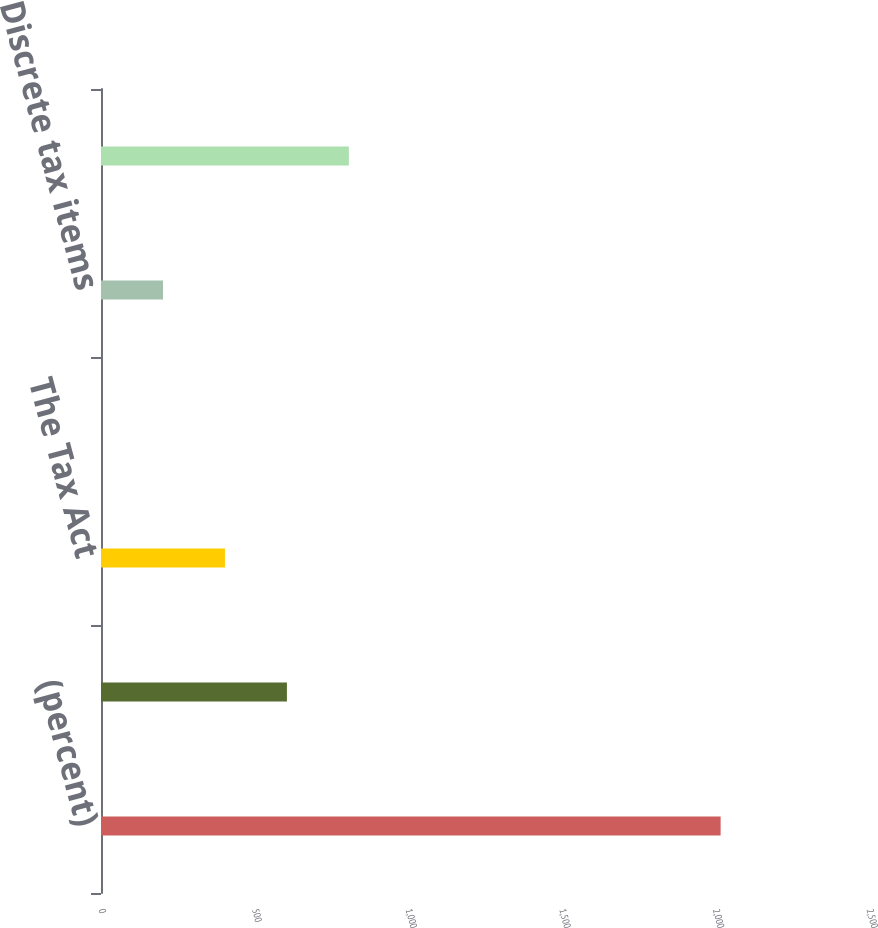Convert chart to OTSL. <chart><loc_0><loc_0><loc_500><loc_500><bar_chart><fcel>(percent)<fcel>Reported GAAP tax rate<fcel>The Tax Act<fcel>Special gains and charges<fcel>Discrete tax items<fcel>Non-GAAP adjusted tax rate<nl><fcel>2017<fcel>605.17<fcel>403.48<fcel>0.1<fcel>201.79<fcel>806.86<nl></chart> 